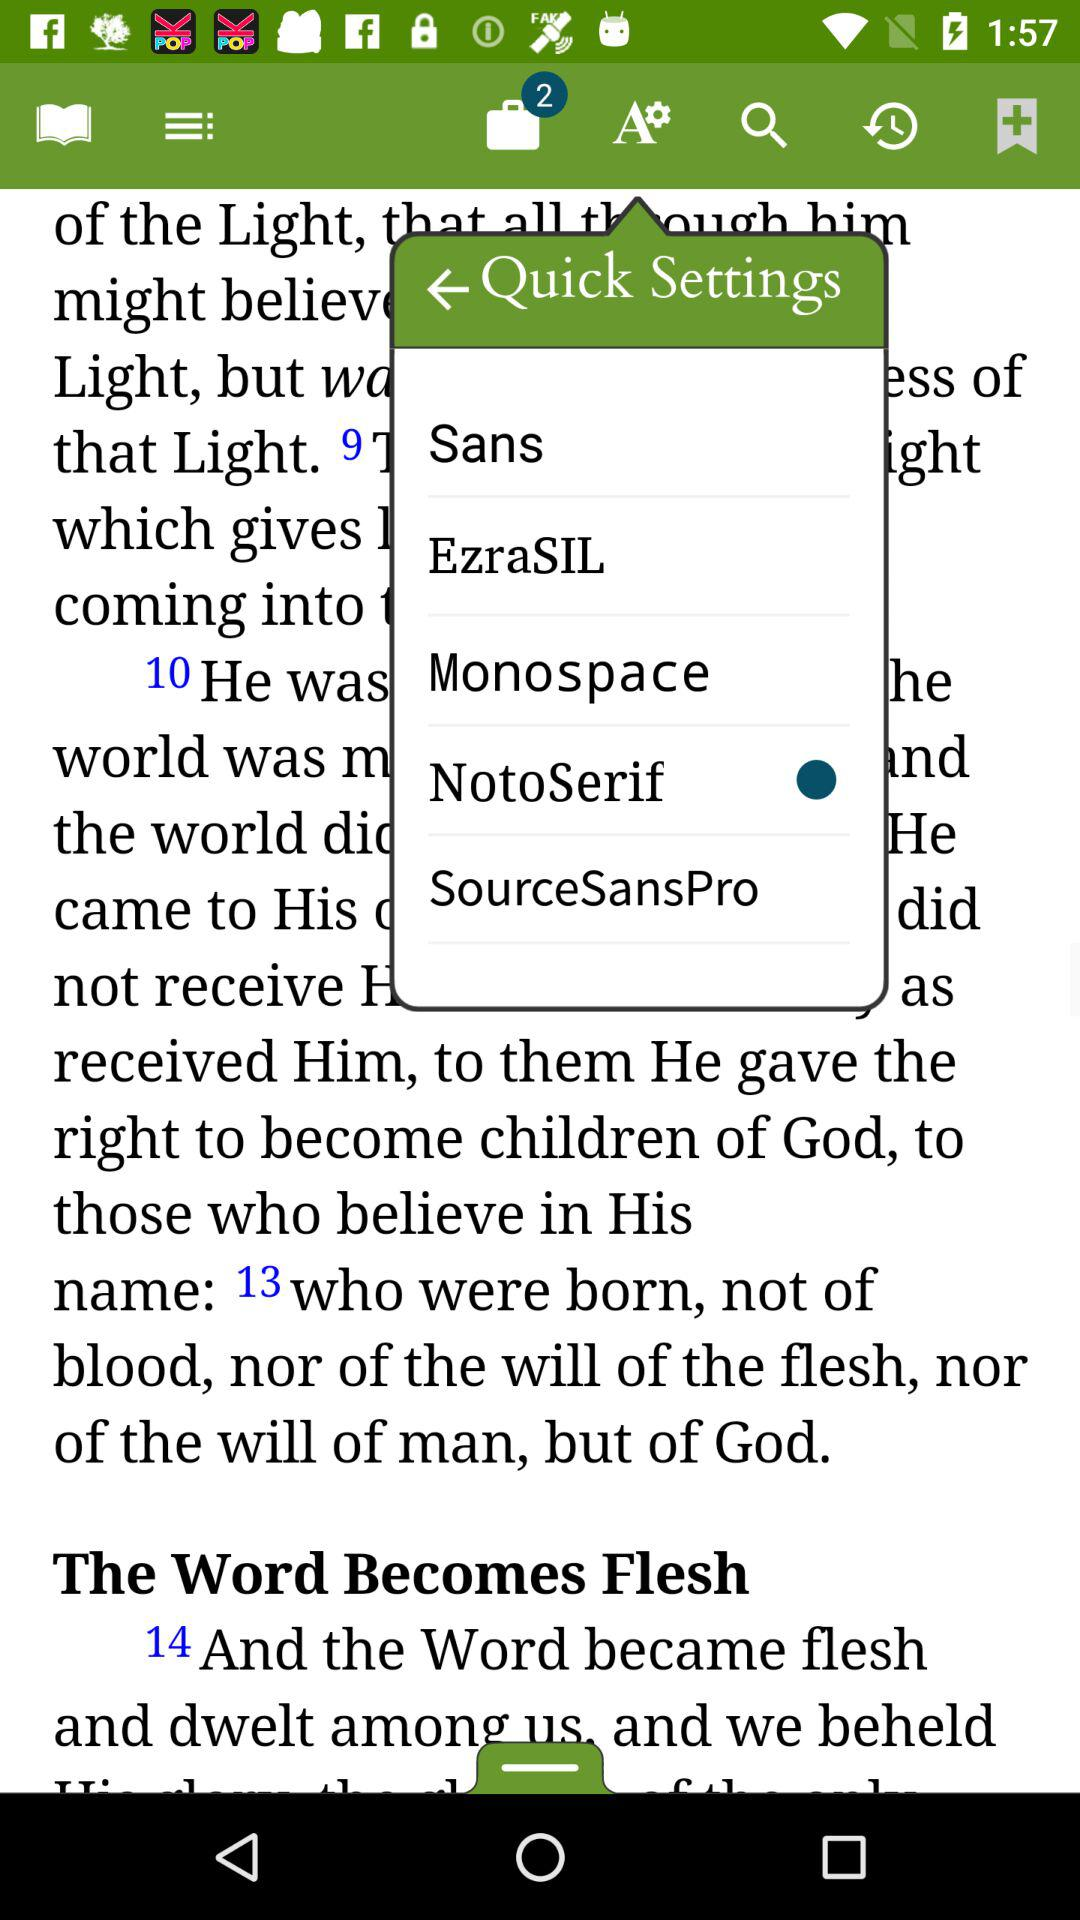How many unread notifications are there? There are 2 unread notifications. 